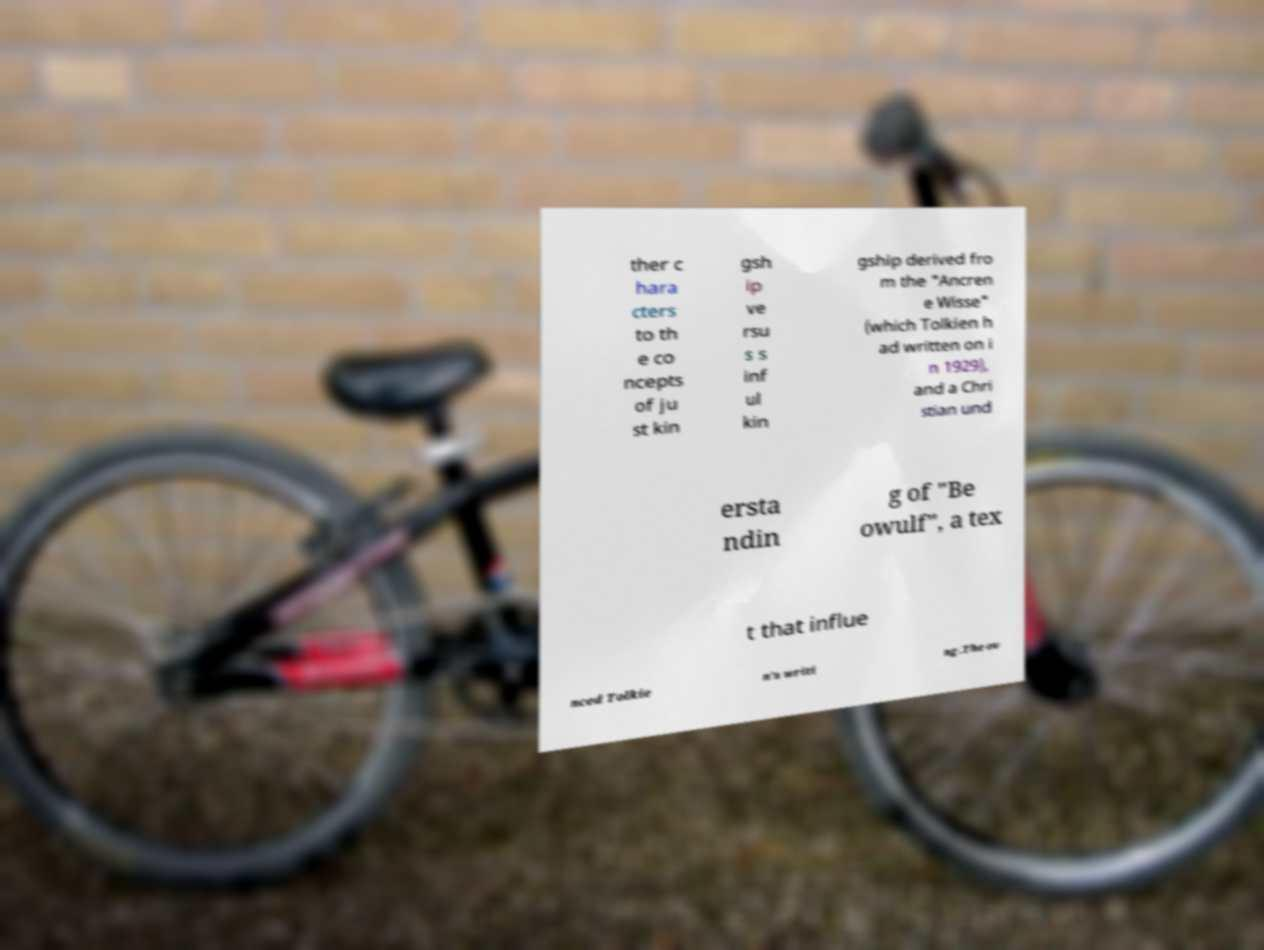Please read and relay the text visible in this image. What does it say? ther c hara cters to th e co ncepts of ju st kin gsh ip ve rsu s s inf ul kin gship derived fro m the "Ancren e Wisse" (which Tolkien h ad written on i n 1929), and a Chri stian und ersta ndin g of "Be owulf", a tex t that influe nced Tolkie n's writi ng.The ov 